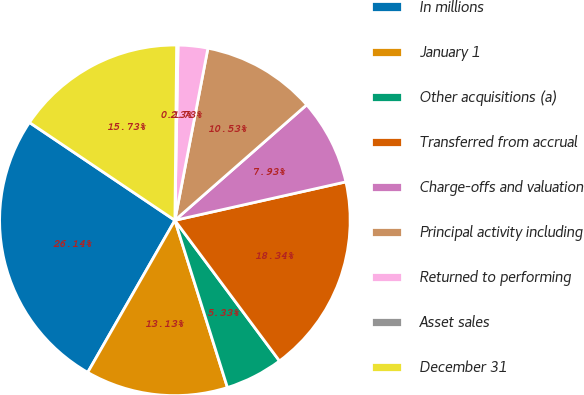<chart> <loc_0><loc_0><loc_500><loc_500><pie_chart><fcel>In millions<fcel>January 1<fcel>Other acquisitions (a)<fcel>Transferred from accrual<fcel>Charge-offs and valuation<fcel>Principal activity including<fcel>Returned to performing<fcel>Asset sales<fcel>December 31<nl><fcel>26.14%<fcel>13.13%<fcel>5.33%<fcel>18.34%<fcel>7.93%<fcel>10.53%<fcel>2.73%<fcel>0.13%<fcel>15.73%<nl></chart> 